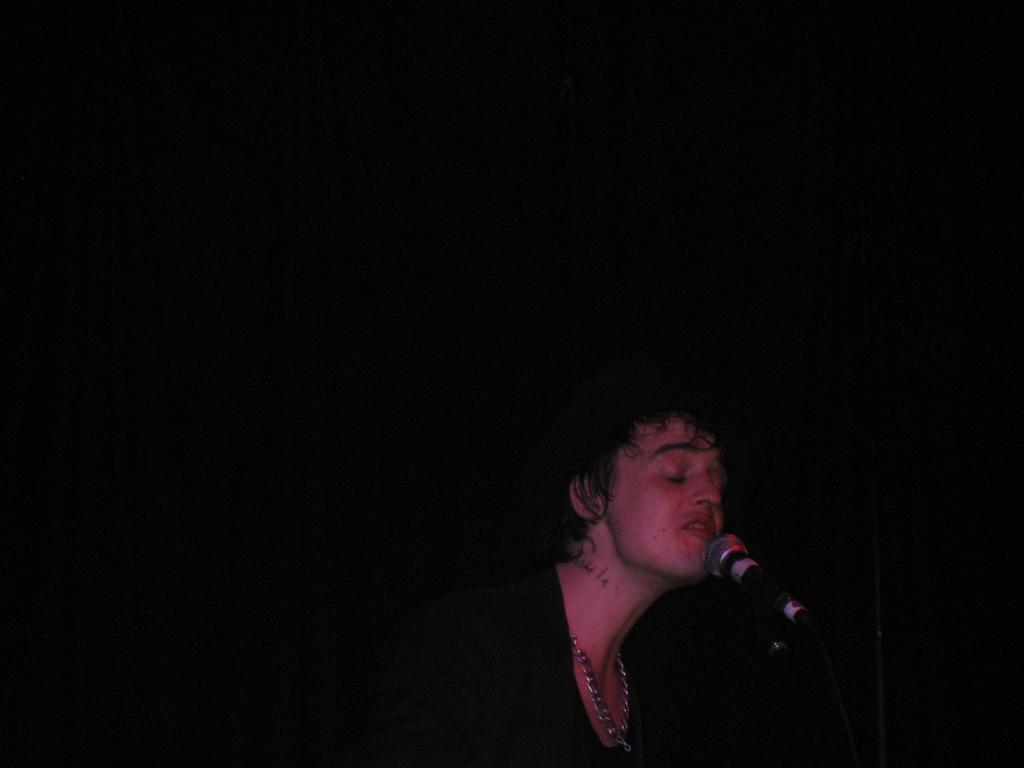Who or what is the main subject in the image? There is a person in the image. What is the person doing in the image? The person is in front of a microphone. Can you describe the background of the image? The background of the image is dark in color. Based on the dark background, can we make any assumptions about the time of day the image was taken? The image may have been taken during the night, as the dark background suggests a lack of natural light. How many boats can be seen in the image? There are no boats present in the image; it features a person in front of a microphone with a dark background. What type of spacecraft is visible in the image? There is no spacecraft present in the image; it features a person in front of a microphone with a dark background. 